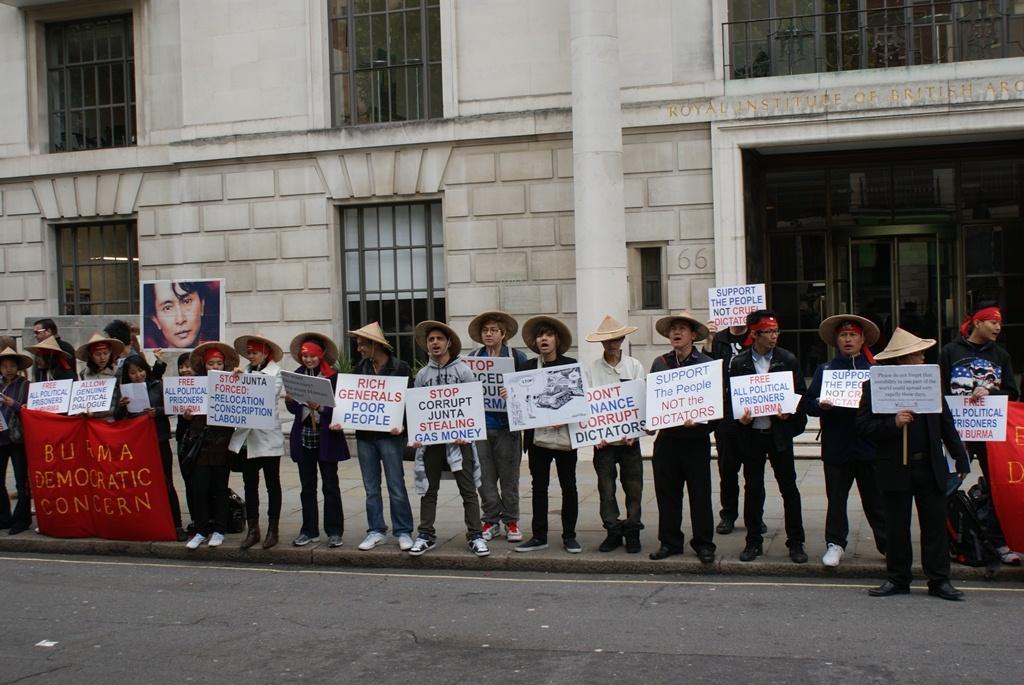Please provide a concise description of this image. In this image there are people standing on the pavement. Bottom of the image there is a road. People are holding the boards. They are wearing the caps. Left side there are few people holding the banner which is having some text. There is a poster having the photo of a person. Background there is a building having doors and windows. Right side there is a person holding a banner. 